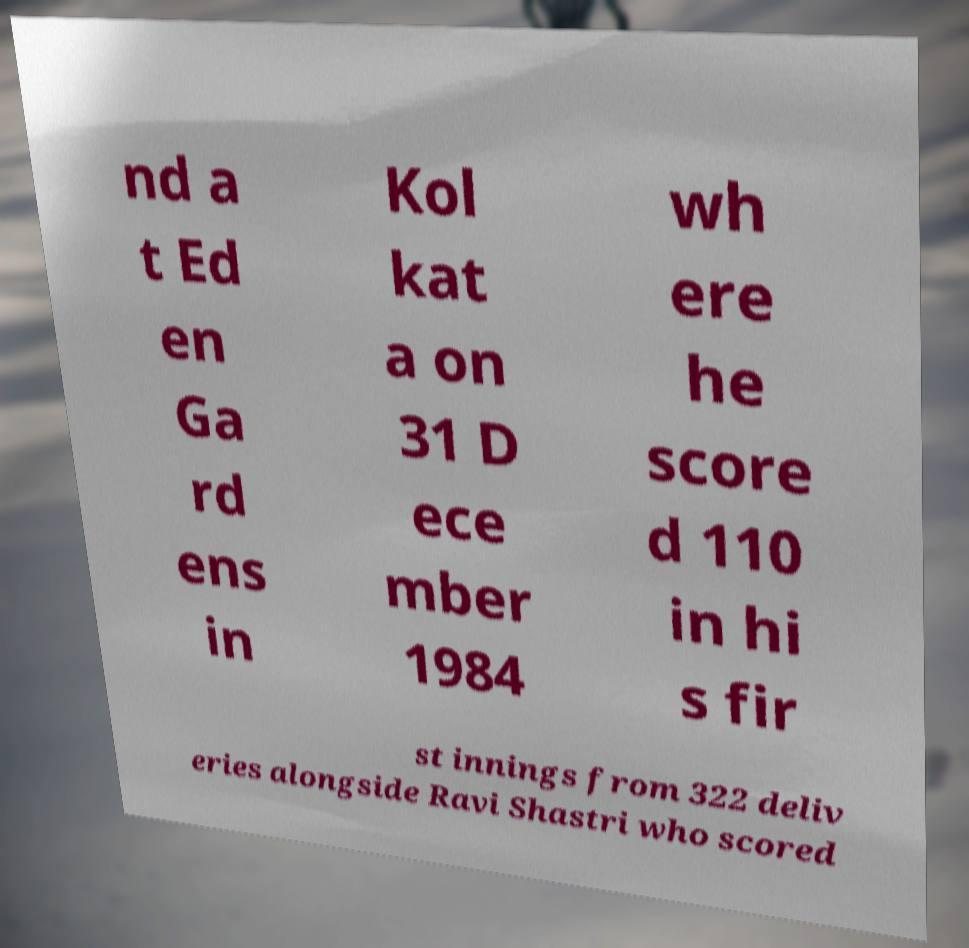Could you extract and type out the text from this image? nd a t Ed en Ga rd ens in Kol kat a on 31 D ece mber 1984 wh ere he score d 110 in hi s fir st innings from 322 deliv eries alongside Ravi Shastri who scored 